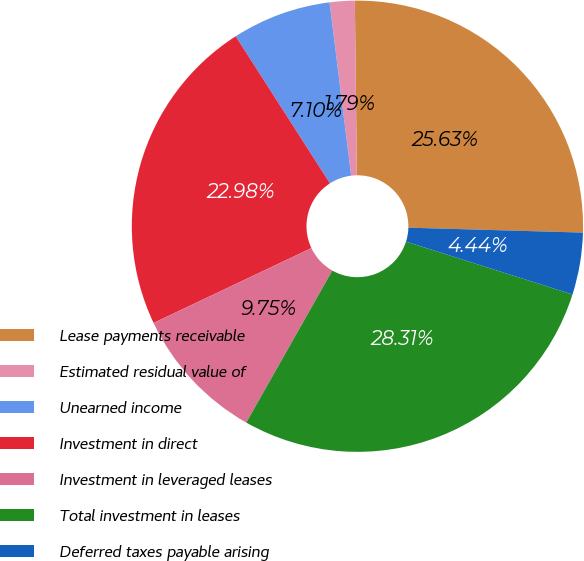<chart> <loc_0><loc_0><loc_500><loc_500><pie_chart><fcel>Lease payments receivable<fcel>Estimated residual value of<fcel>Unearned income<fcel>Investment in direct<fcel>Investment in leveraged leases<fcel>Total investment in leases<fcel>Deferred taxes payable arising<nl><fcel>25.63%<fcel>1.79%<fcel>7.1%<fcel>22.98%<fcel>9.75%<fcel>28.31%<fcel>4.44%<nl></chart> 